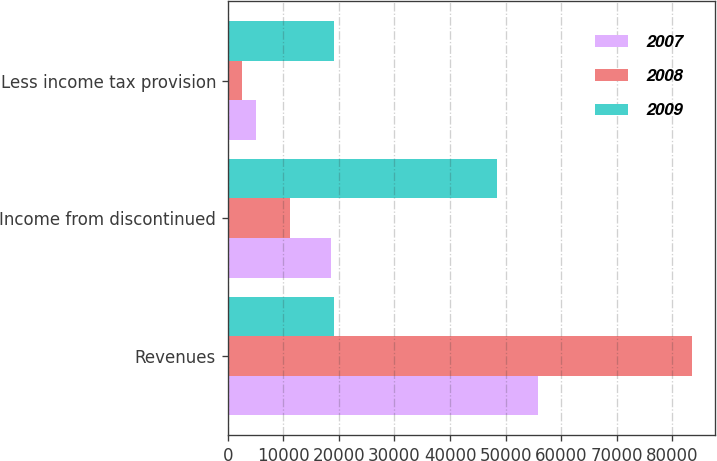Convert chart to OTSL. <chart><loc_0><loc_0><loc_500><loc_500><stacked_bar_chart><ecel><fcel>Revenues<fcel>Income from discontinued<fcel>Less income tax provision<nl><fcel>2007<fcel>55871<fcel>18549<fcel>5014<nl><fcel>2008<fcel>83555<fcel>11129<fcel>2585<nl><fcel>2009<fcel>19131<fcel>48514<fcel>19131<nl></chart> 